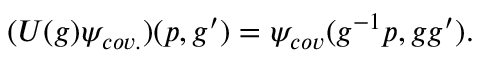Convert formula to latex. <formula><loc_0><loc_0><loc_500><loc_500>( U ( g ) \psi _ { c o v . } ) ( p , g ^ { \prime } ) = \psi _ { c o v } ( g ^ { - 1 } p , g g ^ { \prime } ) .</formula> 